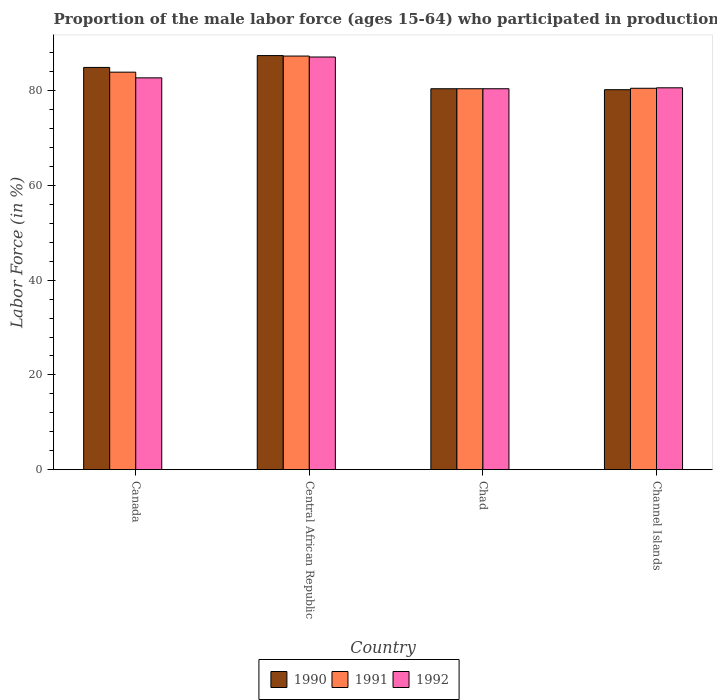How many different coloured bars are there?
Keep it short and to the point. 3. How many bars are there on the 2nd tick from the left?
Offer a very short reply. 3. How many bars are there on the 2nd tick from the right?
Ensure brevity in your answer.  3. What is the label of the 4th group of bars from the left?
Provide a succinct answer. Channel Islands. In how many cases, is the number of bars for a given country not equal to the number of legend labels?
Your response must be concise. 0. What is the proportion of the male labor force who participated in production in 1991 in Channel Islands?
Provide a short and direct response. 80.5. Across all countries, what is the maximum proportion of the male labor force who participated in production in 1990?
Make the answer very short. 87.4. Across all countries, what is the minimum proportion of the male labor force who participated in production in 1991?
Your answer should be compact. 80.4. In which country was the proportion of the male labor force who participated in production in 1990 maximum?
Your answer should be very brief. Central African Republic. In which country was the proportion of the male labor force who participated in production in 1990 minimum?
Offer a terse response. Channel Islands. What is the total proportion of the male labor force who participated in production in 1990 in the graph?
Offer a terse response. 332.9. What is the difference between the proportion of the male labor force who participated in production in 1990 in Canada and that in Channel Islands?
Provide a succinct answer. 4.7. What is the difference between the proportion of the male labor force who participated in production in 1992 in Channel Islands and the proportion of the male labor force who participated in production in 1990 in Canada?
Keep it short and to the point. -4.3. What is the average proportion of the male labor force who participated in production in 1991 per country?
Provide a short and direct response. 83.03. What is the difference between the proportion of the male labor force who participated in production of/in 1990 and proportion of the male labor force who participated in production of/in 1991 in Canada?
Provide a succinct answer. 1. In how many countries, is the proportion of the male labor force who participated in production in 1991 greater than 64 %?
Your answer should be very brief. 4. What is the ratio of the proportion of the male labor force who participated in production in 1991 in Canada to that in Central African Republic?
Keep it short and to the point. 0.96. Is the proportion of the male labor force who participated in production in 1990 in Canada less than that in Chad?
Give a very brief answer. No. What is the difference between the highest and the second highest proportion of the male labor force who participated in production in 1991?
Your response must be concise. -3.4. What is the difference between the highest and the lowest proportion of the male labor force who participated in production in 1991?
Ensure brevity in your answer.  6.9. In how many countries, is the proportion of the male labor force who participated in production in 1992 greater than the average proportion of the male labor force who participated in production in 1992 taken over all countries?
Your answer should be compact. 1. Is it the case that in every country, the sum of the proportion of the male labor force who participated in production in 1990 and proportion of the male labor force who participated in production in 1991 is greater than the proportion of the male labor force who participated in production in 1992?
Offer a terse response. Yes. Are all the bars in the graph horizontal?
Give a very brief answer. No. How many countries are there in the graph?
Ensure brevity in your answer.  4. Does the graph contain grids?
Your answer should be compact. No. What is the title of the graph?
Your answer should be very brief. Proportion of the male labor force (ages 15-64) who participated in production. What is the label or title of the X-axis?
Make the answer very short. Country. What is the label or title of the Y-axis?
Offer a very short reply. Labor Force (in %). What is the Labor Force (in %) of 1990 in Canada?
Your response must be concise. 84.9. What is the Labor Force (in %) in 1991 in Canada?
Offer a very short reply. 83.9. What is the Labor Force (in %) of 1992 in Canada?
Your response must be concise. 82.7. What is the Labor Force (in %) in 1990 in Central African Republic?
Give a very brief answer. 87.4. What is the Labor Force (in %) of 1991 in Central African Republic?
Give a very brief answer. 87.3. What is the Labor Force (in %) in 1992 in Central African Republic?
Provide a short and direct response. 87.1. What is the Labor Force (in %) of 1990 in Chad?
Offer a very short reply. 80.4. What is the Labor Force (in %) in 1991 in Chad?
Make the answer very short. 80.4. What is the Labor Force (in %) in 1992 in Chad?
Ensure brevity in your answer.  80.4. What is the Labor Force (in %) of 1990 in Channel Islands?
Offer a terse response. 80.2. What is the Labor Force (in %) in 1991 in Channel Islands?
Offer a terse response. 80.5. What is the Labor Force (in %) in 1992 in Channel Islands?
Offer a terse response. 80.6. Across all countries, what is the maximum Labor Force (in %) in 1990?
Offer a terse response. 87.4. Across all countries, what is the maximum Labor Force (in %) in 1991?
Your response must be concise. 87.3. Across all countries, what is the maximum Labor Force (in %) in 1992?
Ensure brevity in your answer.  87.1. Across all countries, what is the minimum Labor Force (in %) in 1990?
Offer a terse response. 80.2. Across all countries, what is the minimum Labor Force (in %) of 1991?
Make the answer very short. 80.4. Across all countries, what is the minimum Labor Force (in %) in 1992?
Your response must be concise. 80.4. What is the total Labor Force (in %) in 1990 in the graph?
Give a very brief answer. 332.9. What is the total Labor Force (in %) of 1991 in the graph?
Ensure brevity in your answer.  332.1. What is the total Labor Force (in %) of 1992 in the graph?
Provide a succinct answer. 330.8. What is the difference between the Labor Force (in %) of 1991 in Canada and that in Central African Republic?
Your response must be concise. -3.4. What is the difference between the Labor Force (in %) in 1991 in Canada and that in Chad?
Make the answer very short. 3.5. What is the difference between the Labor Force (in %) of 1992 in Canada and that in Chad?
Give a very brief answer. 2.3. What is the difference between the Labor Force (in %) of 1991 in Canada and that in Channel Islands?
Make the answer very short. 3.4. What is the difference between the Labor Force (in %) of 1992 in Canada and that in Channel Islands?
Ensure brevity in your answer.  2.1. What is the difference between the Labor Force (in %) of 1990 in Central African Republic and that in Chad?
Make the answer very short. 7. What is the difference between the Labor Force (in %) in 1991 in Central African Republic and that in Chad?
Provide a succinct answer. 6.9. What is the difference between the Labor Force (in %) of 1990 in Canada and the Labor Force (in %) of 1992 in Central African Republic?
Ensure brevity in your answer.  -2.2. What is the difference between the Labor Force (in %) of 1991 in Canada and the Labor Force (in %) of 1992 in Central African Republic?
Make the answer very short. -3.2. What is the difference between the Labor Force (in %) of 1990 in Canada and the Labor Force (in %) of 1991 in Chad?
Give a very brief answer. 4.5. What is the difference between the Labor Force (in %) in 1991 in Canada and the Labor Force (in %) in 1992 in Channel Islands?
Provide a short and direct response. 3.3. What is the difference between the Labor Force (in %) of 1990 in Central African Republic and the Labor Force (in %) of 1991 in Chad?
Make the answer very short. 7. What is the difference between the Labor Force (in %) of 1990 in Central African Republic and the Labor Force (in %) of 1992 in Channel Islands?
Give a very brief answer. 6.8. What is the difference between the Labor Force (in %) of 1990 in Chad and the Labor Force (in %) of 1991 in Channel Islands?
Give a very brief answer. -0.1. What is the difference between the Labor Force (in %) in 1990 in Chad and the Labor Force (in %) in 1992 in Channel Islands?
Provide a short and direct response. -0.2. What is the difference between the Labor Force (in %) in 1991 in Chad and the Labor Force (in %) in 1992 in Channel Islands?
Offer a terse response. -0.2. What is the average Labor Force (in %) in 1990 per country?
Keep it short and to the point. 83.22. What is the average Labor Force (in %) of 1991 per country?
Give a very brief answer. 83.03. What is the average Labor Force (in %) in 1992 per country?
Offer a terse response. 82.7. What is the difference between the Labor Force (in %) in 1990 and Labor Force (in %) in 1991 in Canada?
Provide a short and direct response. 1. What is the difference between the Labor Force (in %) in 1991 and Labor Force (in %) in 1992 in Canada?
Provide a succinct answer. 1.2. What is the difference between the Labor Force (in %) in 1991 and Labor Force (in %) in 1992 in Central African Republic?
Your answer should be very brief. 0.2. What is the difference between the Labor Force (in %) of 1990 and Labor Force (in %) of 1991 in Chad?
Your response must be concise. 0. What is the difference between the Labor Force (in %) of 1990 and Labor Force (in %) of 1992 in Chad?
Your answer should be compact. 0. What is the difference between the Labor Force (in %) in 1991 and Labor Force (in %) in 1992 in Channel Islands?
Your answer should be compact. -0.1. What is the ratio of the Labor Force (in %) of 1990 in Canada to that in Central African Republic?
Give a very brief answer. 0.97. What is the ratio of the Labor Force (in %) of 1991 in Canada to that in Central African Republic?
Keep it short and to the point. 0.96. What is the ratio of the Labor Force (in %) in 1992 in Canada to that in Central African Republic?
Ensure brevity in your answer.  0.95. What is the ratio of the Labor Force (in %) of 1990 in Canada to that in Chad?
Give a very brief answer. 1.06. What is the ratio of the Labor Force (in %) of 1991 in Canada to that in Chad?
Keep it short and to the point. 1.04. What is the ratio of the Labor Force (in %) of 1992 in Canada to that in Chad?
Offer a terse response. 1.03. What is the ratio of the Labor Force (in %) of 1990 in Canada to that in Channel Islands?
Your answer should be very brief. 1.06. What is the ratio of the Labor Force (in %) of 1991 in Canada to that in Channel Islands?
Offer a terse response. 1.04. What is the ratio of the Labor Force (in %) of 1992 in Canada to that in Channel Islands?
Provide a short and direct response. 1.03. What is the ratio of the Labor Force (in %) of 1990 in Central African Republic to that in Chad?
Ensure brevity in your answer.  1.09. What is the ratio of the Labor Force (in %) of 1991 in Central African Republic to that in Chad?
Your answer should be very brief. 1.09. What is the ratio of the Labor Force (in %) in 1990 in Central African Republic to that in Channel Islands?
Provide a succinct answer. 1.09. What is the ratio of the Labor Force (in %) in 1991 in Central African Republic to that in Channel Islands?
Give a very brief answer. 1.08. What is the ratio of the Labor Force (in %) in 1992 in Central African Republic to that in Channel Islands?
Provide a short and direct response. 1.08. What is the difference between the highest and the second highest Labor Force (in %) of 1991?
Provide a succinct answer. 3.4. 